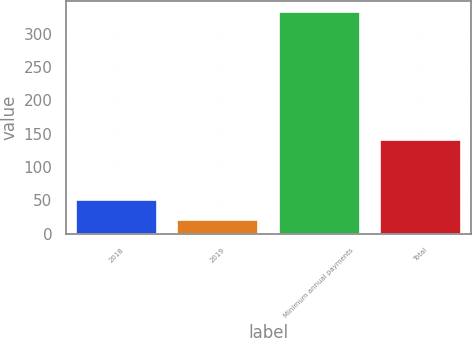Convert chart. <chart><loc_0><loc_0><loc_500><loc_500><bar_chart><fcel>2018<fcel>2019<fcel>Minimum annual payments<fcel>Total<nl><fcel>51.2<fcel>20<fcel>332<fcel>140<nl></chart> 